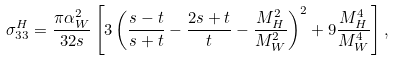Convert formula to latex. <formula><loc_0><loc_0><loc_500><loc_500>\sigma _ { 3 3 } ^ { H } = \frac { \pi \alpha _ { W } ^ { 2 } } { 3 2 s } \left [ 3 \left ( \frac { s - t } { s + t } - \frac { 2 s + t } { t } - \frac { M _ { H } ^ { 2 } } { M _ { W } ^ { 2 } } \right ) ^ { 2 } + 9 \frac { M _ { H } ^ { 4 } } { M _ { W } ^ { 4 } } \right ] ,</formula> 